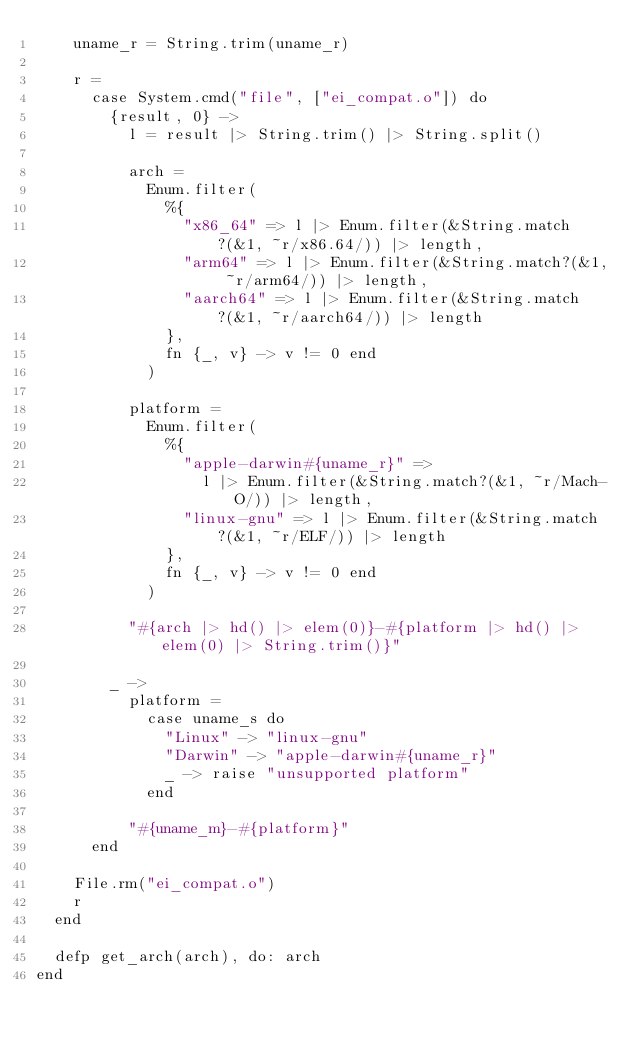<code> <loc_0><loc_0><loc_500><loc_500><_Elixir_>    uname_r = String.trim(uname_r)

    r =
      case System.cmd("file", ["ei_compat.o"]) do
        {result, 0} ->
          l = result |> String.trim() |> String.split()

          arch =
            Enum.filter(
              %{
                "x86_64" => l |> Enum.filter(&String.match?(&1, ~r/x86.64/)) |> length,
                "arm64" => l |> Enum.filter(&String.match?(&1, ~r/arm64/)) |> length,
                "aarch64" => l |> Enum.filter(&String.match?(&1, ~r/aarch64/)) |> length
              },
              fn {_, v} -> v != 0 end
            )

          platform =
            Enum.filter(
              %{
                "apple-darwin#{uname_r}" =>
                  l |> Enum.filter(&String.match?(&1, ~r/Mach-O/)) |> length,
                "linux-gnu" => l |> Enum.filter(&String.match?(&1, ~r/ELF/)) |> length
              },
              fn {_, v} -> v != 0 end
            )

          "#{arch |> hd() |> elem(0)}-#{platform |> hd() |> elem(0) |> String.trim()}"

        _ ->
          platform =
            case uname_s do
              "Linux" -> "linux-gnu"
              "Darwin" -> "apple-darwin#{uname_r}"
              _ -> raise "unsupported platform"
            end

          "#{uname_m}-#{platform}"
      end

    File.rm("ei_compat.o")
    r
  end

  defp get_arch(arch), do: arch
end
</code> 